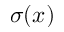<formula> <loc_0><loc_0><loc_500><loc_500>\sigma ( x )</formula> 